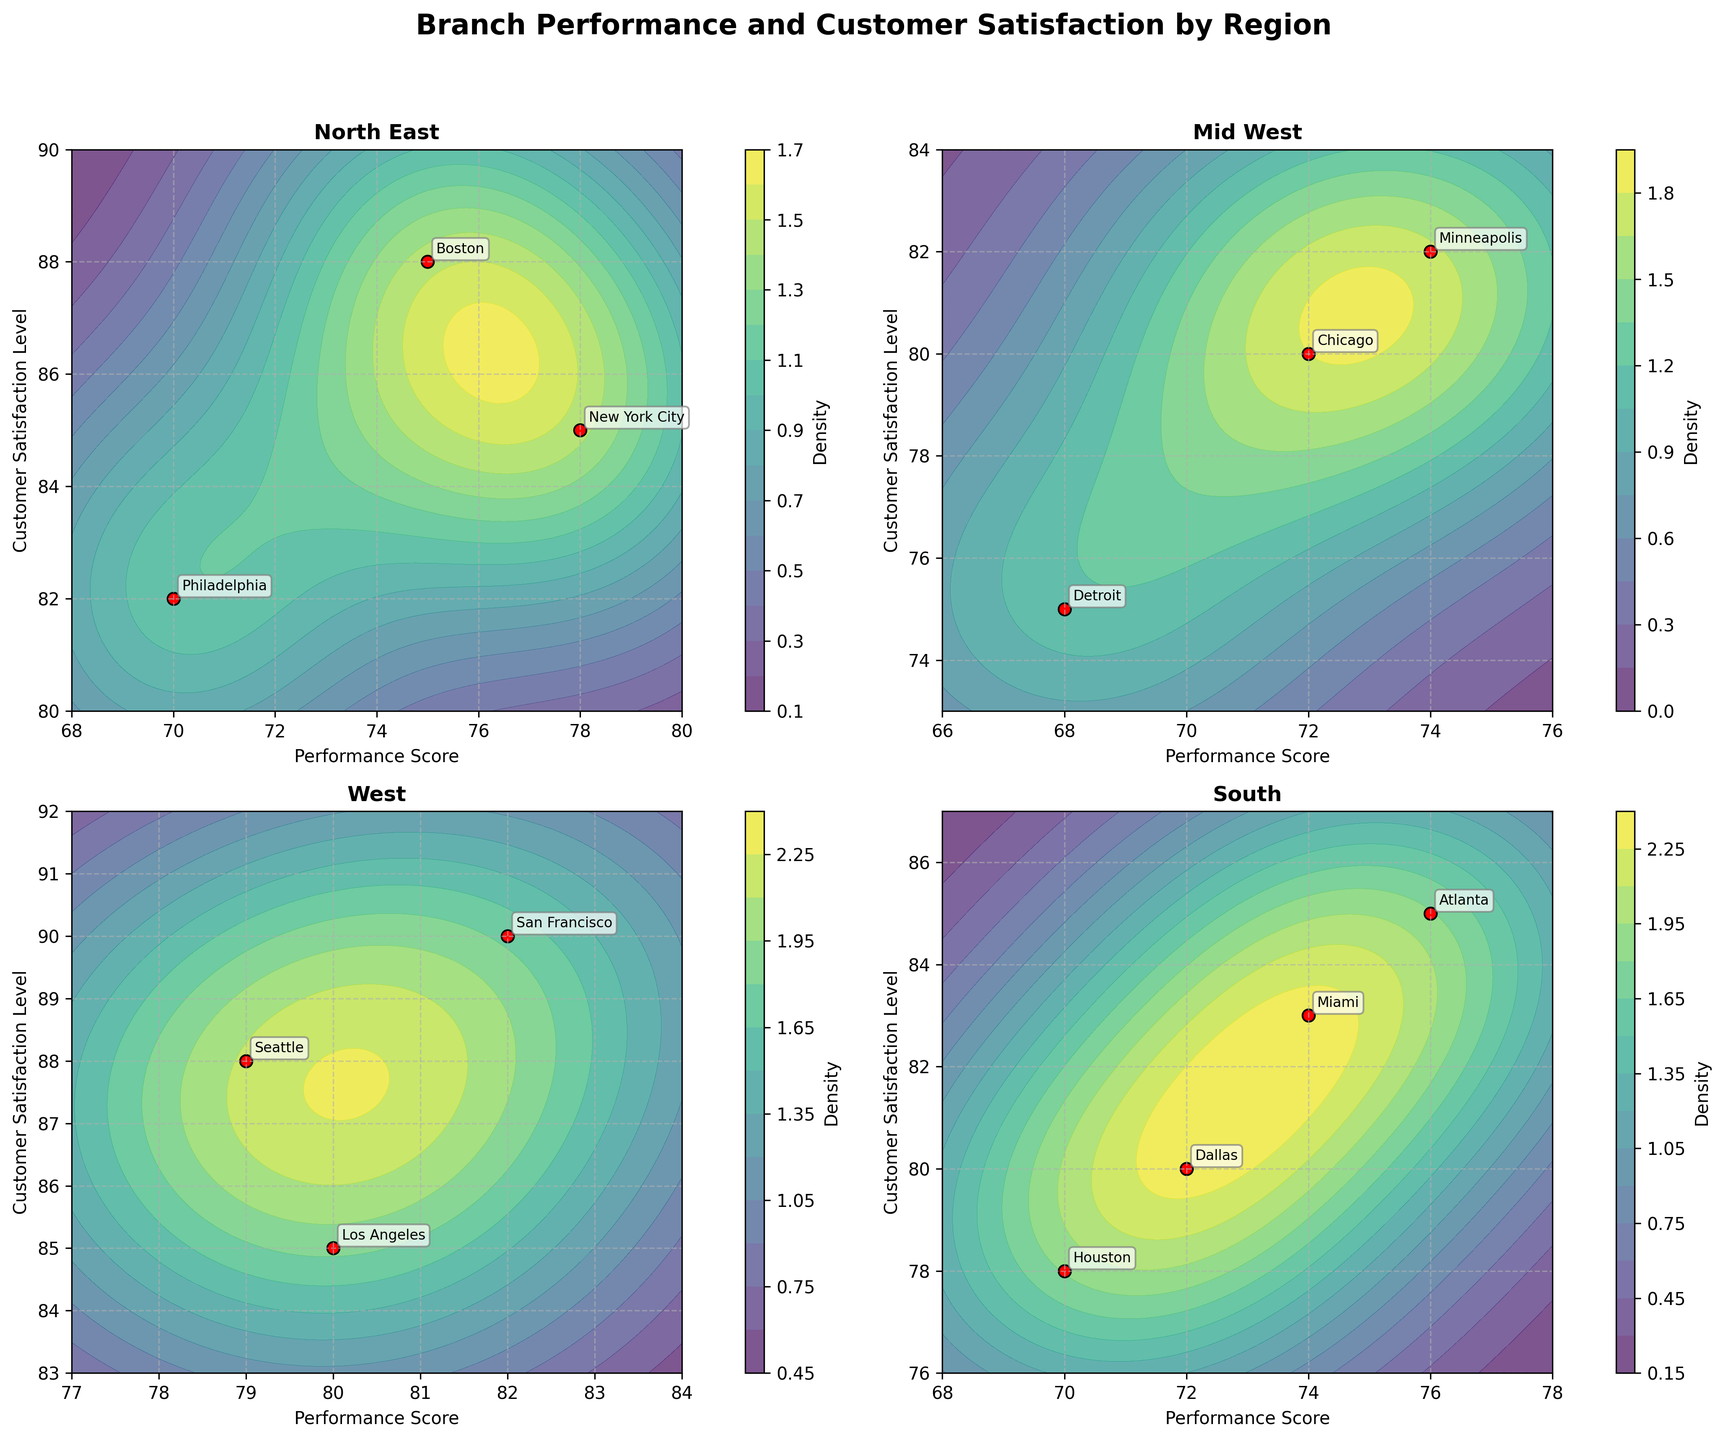What is the title of the plot? The title is given at the top of the figure and reads 'Branch Performance and Customer Satisfaction by Region'.
Answer: 'Branch Performance and Customer Satisfaction by Region' How many regions are represented in the subplots? There are four subplots indicating the presence of four different regions as each subplot corresponds to a different region.
Answer: 4 Which region shows the highest customer satisfaction level? According to the scatter points, San Francisco in the West region has the highest customer satisfaction level with a score of 90.
Answer: West (San Francisco) Which branch in the South region has the highest performance score? In the South region subplot, Atlanta has the highest performance score, which is 76.
Answer: Atlanta What are the x and y axes labeled as? Each subplot has the x-axis labeled as 'Performance Score' and the y-axis labeled as 'Customer Satisfaction Level'.
Answer: 'Performance Score' and 'Customer Satisfaction Level' Which region has the most balanced performance scores and customer satisfaction levels? By visually assessing the contour density and scatter points, the West region appears most balanced with its branches closely clustered and higher density of satisfaction and performance scores.
Answer: West Compare the range of customer satisfaction levels in the North East and Mid West regions. In the North East region, the range is from 82 to 88, while in the Mid West region, the range is from 75 to 82. The North East has a smaller range but higher average satisfaction.
Answer: North East: 82-88, Mid West: 75-82 Which branch has the lowest customer satisfaction level, and in which region is it located? Detroit in the Mid West region has the lowest customer satisfaction level, which is 75.
Answer: Detroit, Mid West Are there any regions where all branches have a performance score above 70? By reviewing each subplot, we see that the West region has branches with performance scores all above 70 (85, 90, 88).
Answer: West Which region shows the highest density of customer satisfaction levels above 85 in the contour plots? Viewing the contour density, the West region has the highest density of satisfaction levels above 85 as indicated by denser, more concentrated regions above this threshold.
Answer: West 